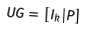Convert formula to latex. <formula><loc_0><loc_0><loc_500><loc_500>U G = [ I _ { k } | P ]</formula> 